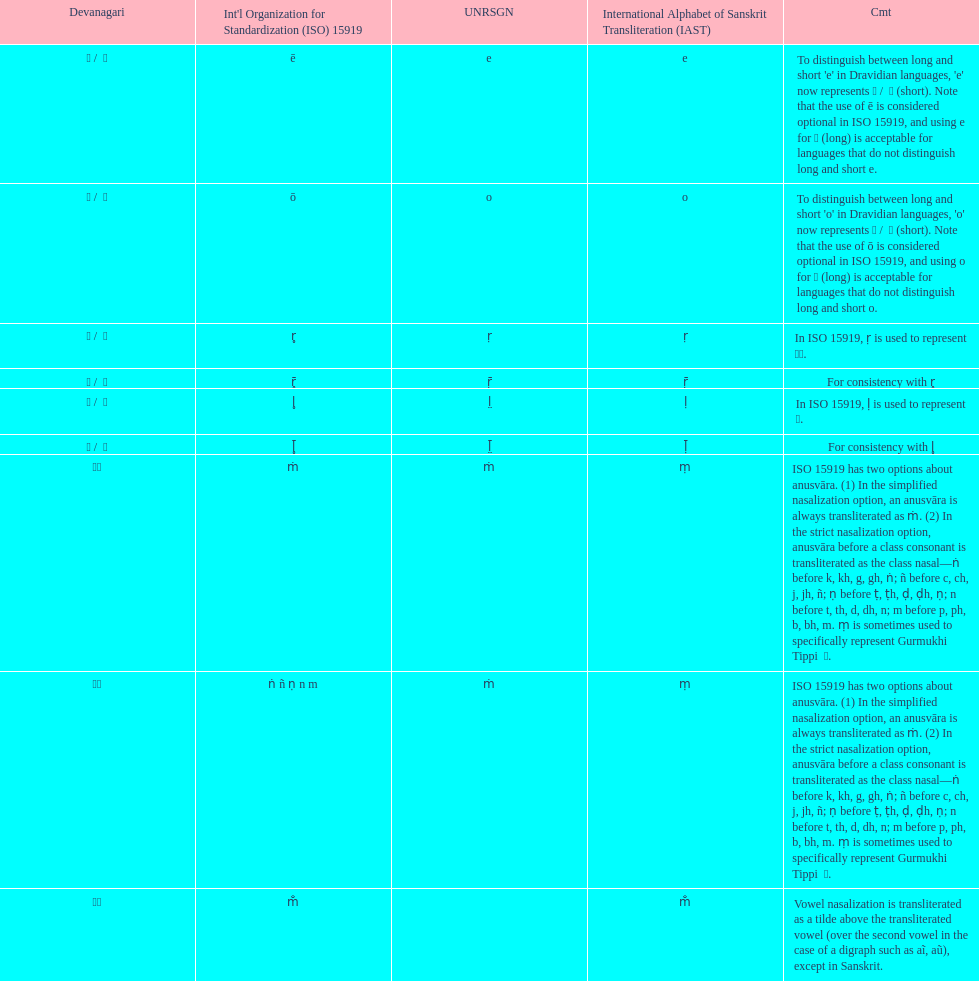What iast is listed before the o? E. 